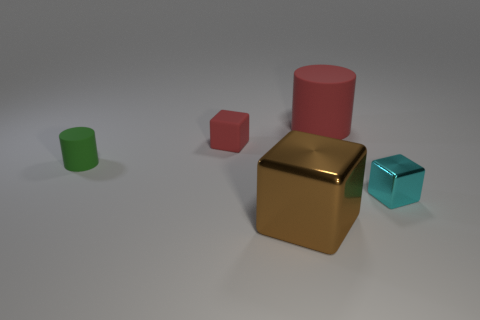The tiny matte cylinder has what color?
Keep it short and to the point. Green. What number of tiny cubes are the same color as the big cylinder?
Offer a terse response. 1. There is a red object that is the same size as the green object; what is its material?
Offer a terse response. Rubber. There is a large thing that is in front of the small rubber cube; are there any red matte things that are on the left side of it?
Your response must be concise. Yes. How many other objects are the same color as the matte block?
Your answer should be compact. 1. The cyan object is what size?
Make the answer very short. Small. Are any brown shiny objects visible?
Offer a terse response. Yes. Is the number of big metal cubes that are in front of the large brown thing greater than the number of small rubber blocks in front of the small green thing?
Provide a short and direct response. No. There is a block that is behind the large metallic cube and on the left side of the red cylinder; what material is it?
Offer a very short reply. Rubber. Is the cyan metal thing the same shape as the big rubber thing?
Keep it short and to the point. No. 